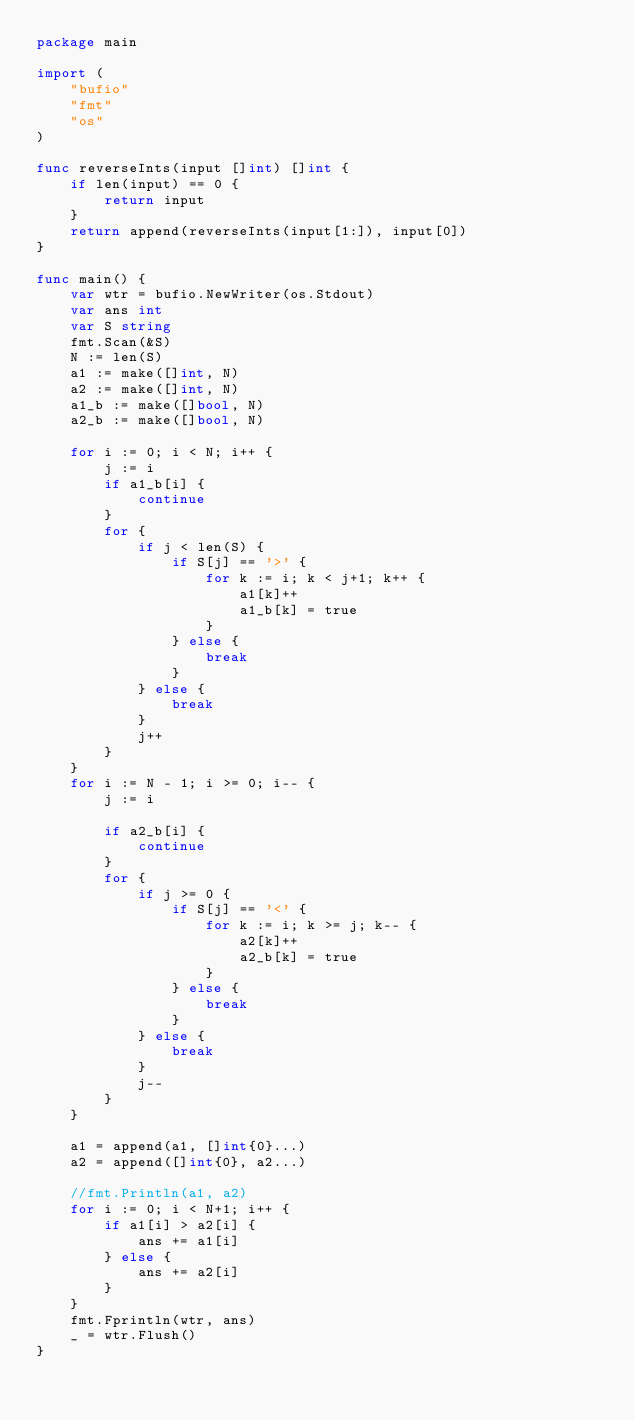Convert code to text. <code><loc_0><loc_0><loc_500><loc_500><_Go_>package main

import (
	"bufio"
	"fmt"
	"os"
)

func reverseInts(input []int) []int {
	if len(input) == 0 {
		return input
	}
	return append(reverseInts(input[1:]), input[0])
}

func main() {
	var wtr = bufio.NewWriter(os.Stdout)
	var ans int
	var S string
	fmt.Scan(&S)
	N := len(S)
	a1 := make([]int, N)
	a2 := make([]int, N)
	a1_b := make([]bool, N)
	a2_b := make([]bool, N)

	for i := 0; i < N; i++ {
		j := i
		if a1_b[i] {
			continue
		}
		for {
			if j < len(S) {
				if S[j] == '>' {
					for k := i; k < j+1; k++ {
						a1[k]++
						a1_b[k] = true
					}
				} else {
					break
				}
			} else {
				break
			}
			j++
		}
	}
	for i := N - 1; i >= 0; i-- {
		j := i

		if a2_b[i] {
			continue
		}
		for {
			if j >= 0 {
				if S[j] == '<' {
					for k := i; k >= j; k-- {
						a2[k]++
						a2_b[k] = true
					}
				} else {
					break
				}
			} else {
				break
			}
			j--
		}
	}

	a1 = append(a1, []int{0}...)
	a2 = append([]int{0}, a2...)

	//fmt.Println(a1, a2)
	for i := 0; i < N+1; i++ {
		if a1[i] > a2[i] {
			ans += a1[i]
		} else {
			ans += a2[i]
		}
	}
	fmt.Fprintln(wtr, ans)
	_ = wtr.Flush()
}
</code> 